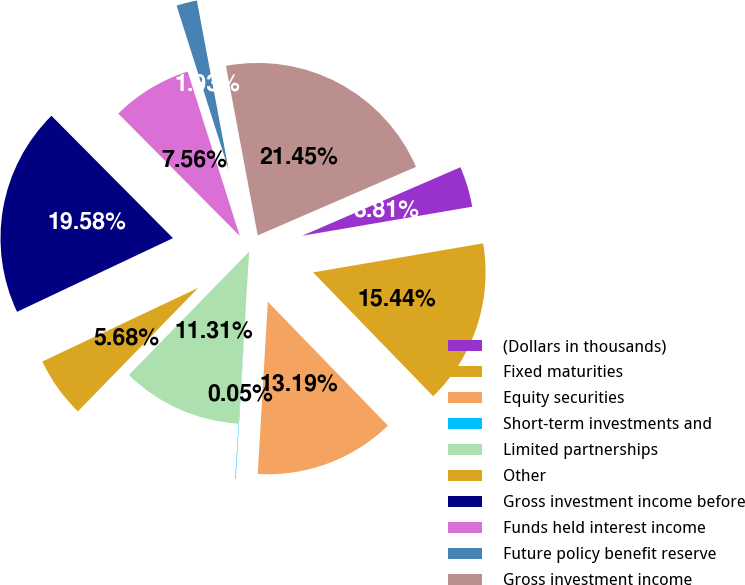Convert chart. <chart><loc_0><loc_0><loc_500><loc_500><pie_chart><fcel>(Dollars in thousands)<fcel>Fixed maturities<fcel>Equity securities<fcel>Short-term investments and<fcel>Limited partnerships<fcel>Other<fcel>Gross investment income before<fcel>Funds held interest income<fcel>Future policy benefit reserve<fcel>Gross investment income<nl><fcel>3.81%<fcel>15.44%<fcel>13.19%<fcel>0.05%<fcel>11.31%<fcel>5.68%<fcel>19.58%<fcel>7.56%<fcel>1.93%<fcel>21.45%<nl></chart> 